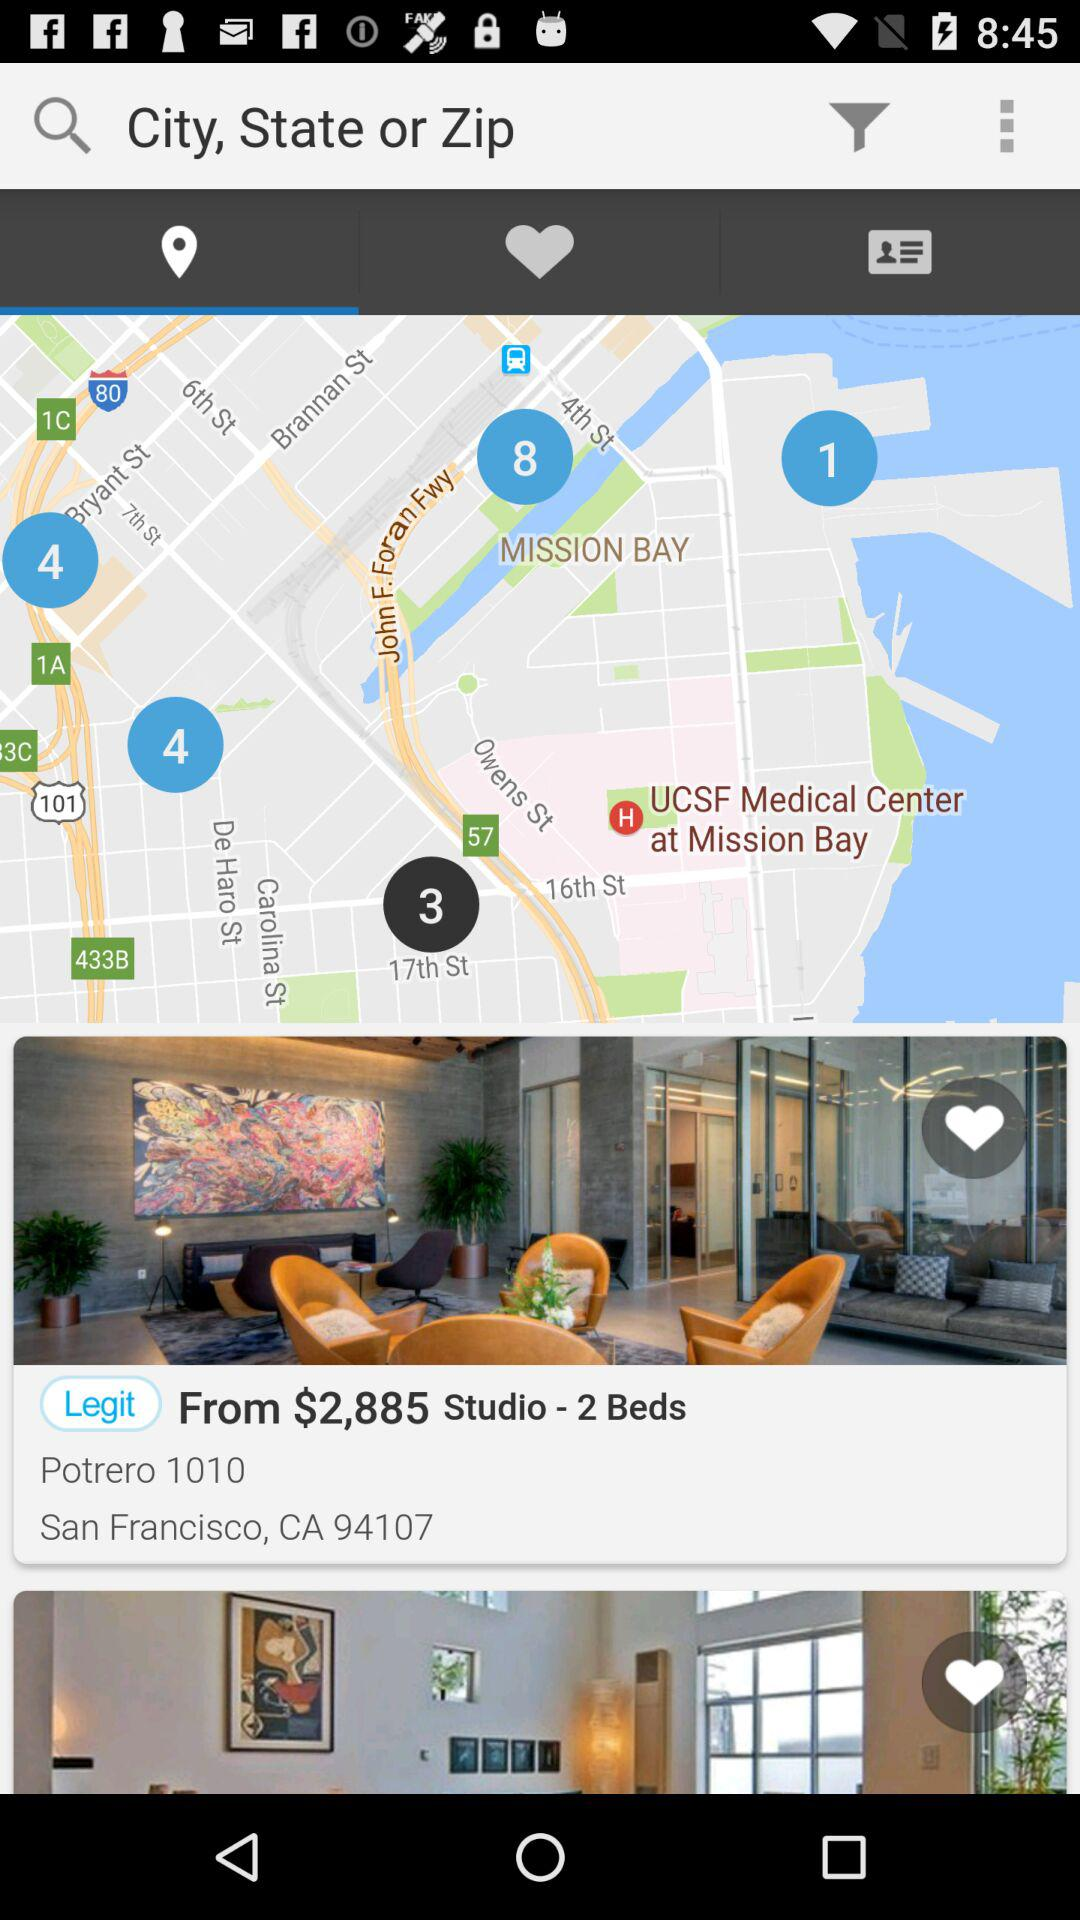What is the starting price of the studio? The starting price of the studio is $2,885. 